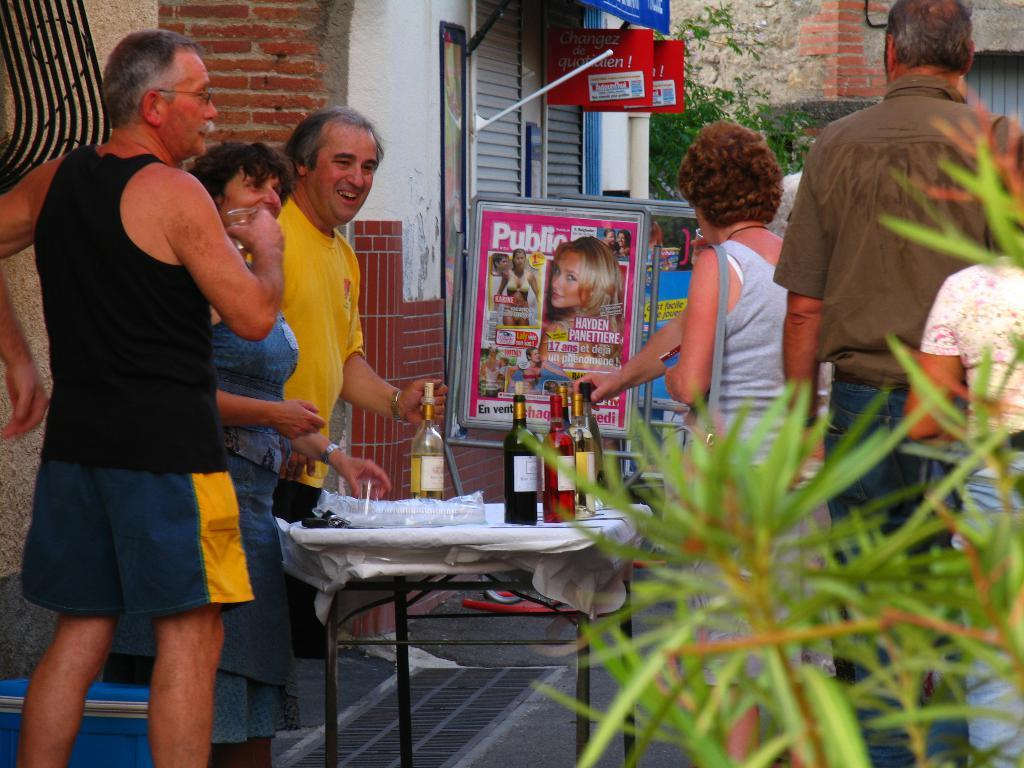<image>
Relay a brief, clear account of the picture shown. Magazine stand which shows a magazine and the word "Public". 